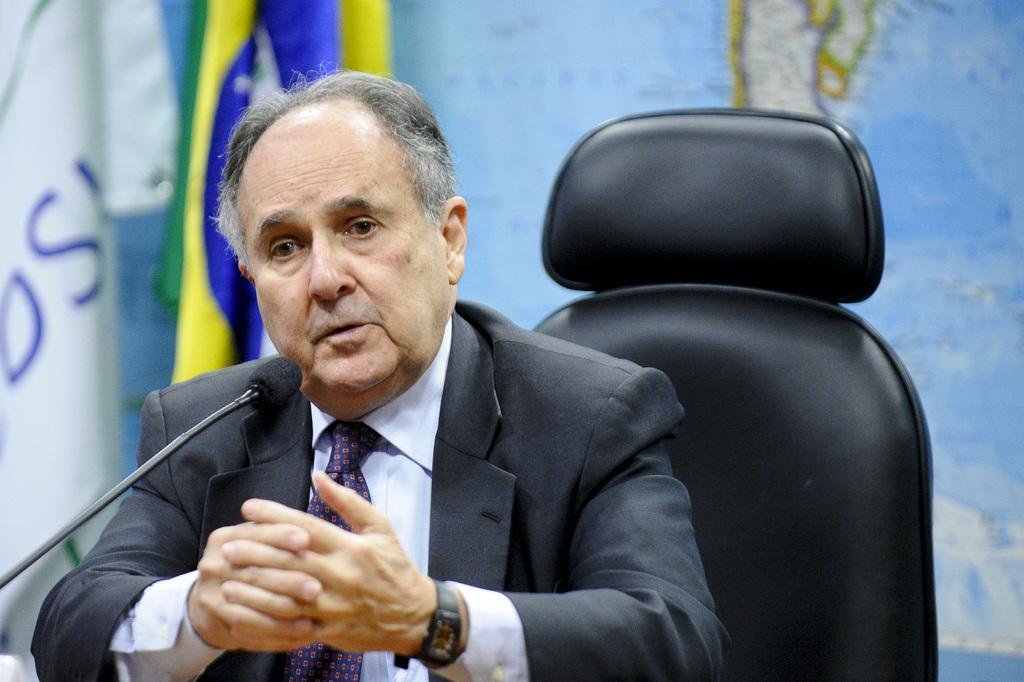Who is the main subject in the image? There is a person in the center of the image. What is the person wearing? The person is wearing a coat and a tie. What is the person doing in the image? The person is sitting on a chair. What object can be seen near the person? There is a mic in the image. What can be seen in the background of the image? There is a flag and a board in the background. What type of noise can be heard coming from the coach in the image? There is no coach present in the image, and therefore no noise can be heard from it. 